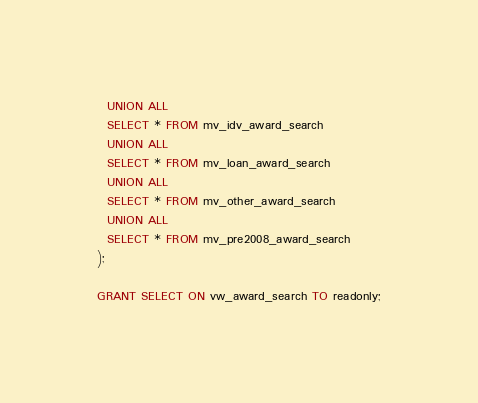Convert code to text. <code><loc_0><loc_0><loc_500><loc_500><_SQL_>  UNION ALL
  SELECT * FROM mv_idv_award_search
  UNION ALL
  SELECT * FROM mv_loan_award_search
  UNION ALL
  SELECT * FROM mv_other_award_search
  UNION ALL
  SELECT * FROM mv_pre2008_award_search
);

GRANT SELECT ON vw_award_search TO readonly;
</code> 